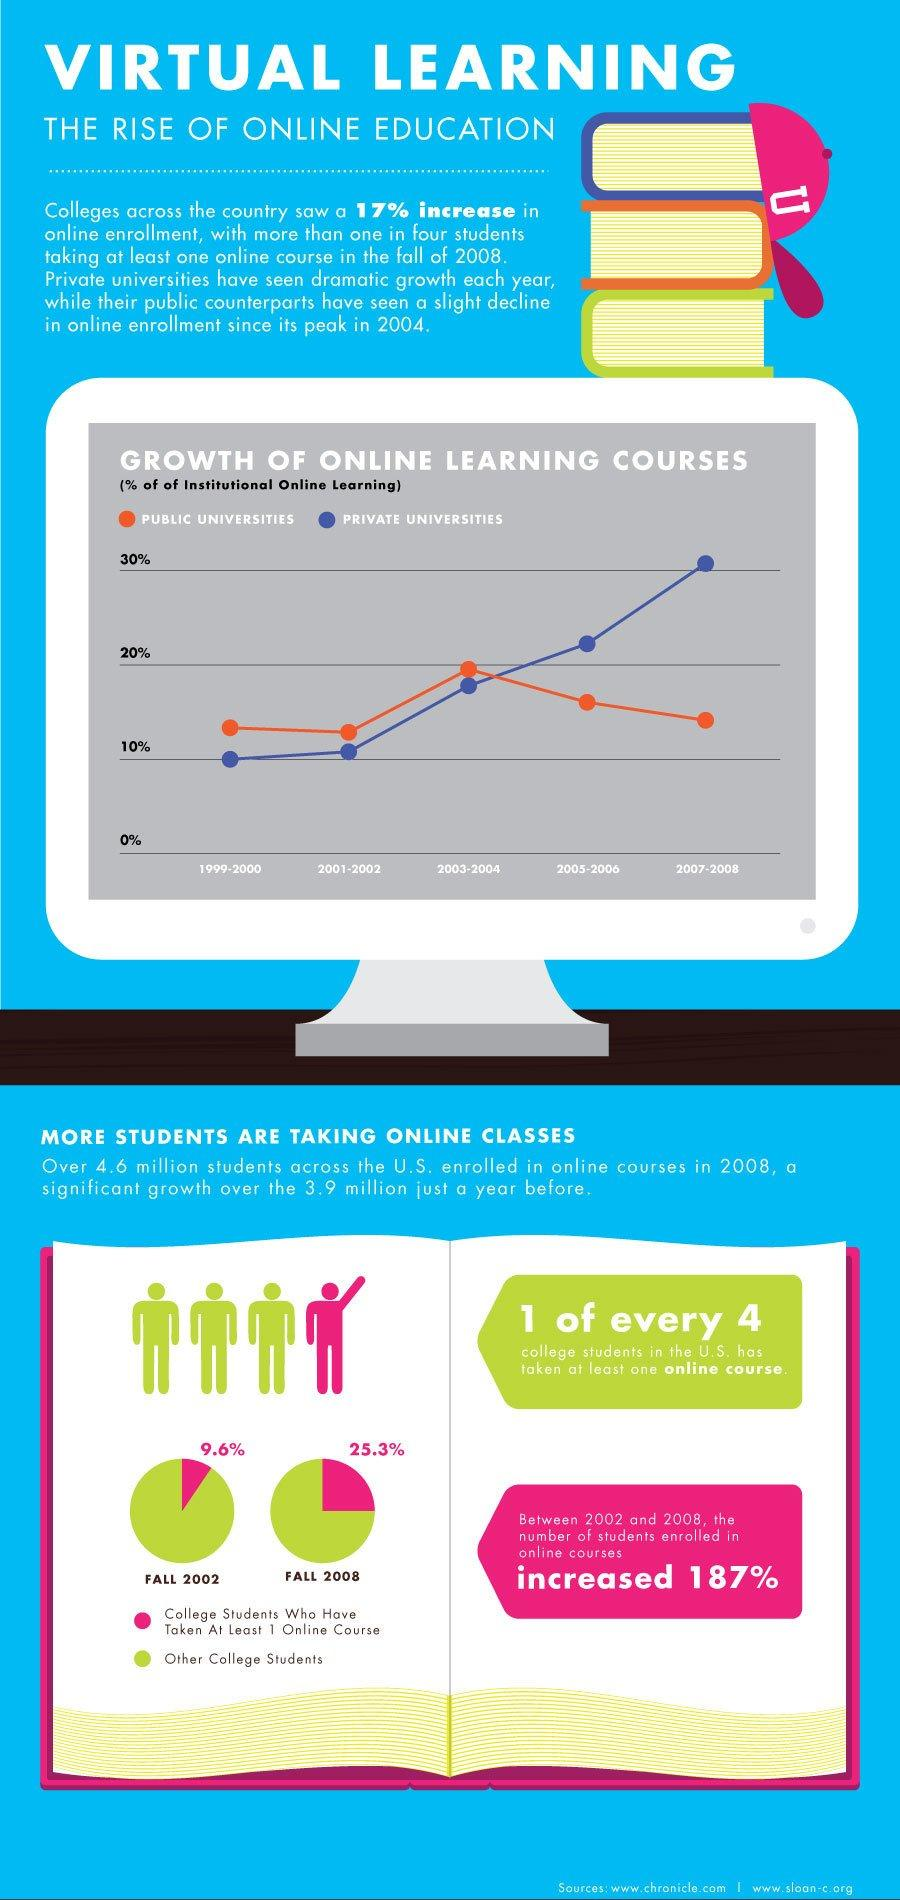Mention a couple of crucial points in this snapshot. During 2005-2006, public universities have seen less than 20% of institutional online learning. During fall 2002, a small percentage of college students in the U.S. had taken at least one online course. Specifically, 9.6% of students had participated in online learning during that time period. In the fall of 2008, 25.3% of college students in the United States had taken at least one online course. During the years 2007-2008, private universities were found to have a higher proportion of institutional online learning compared to other types of universities. 